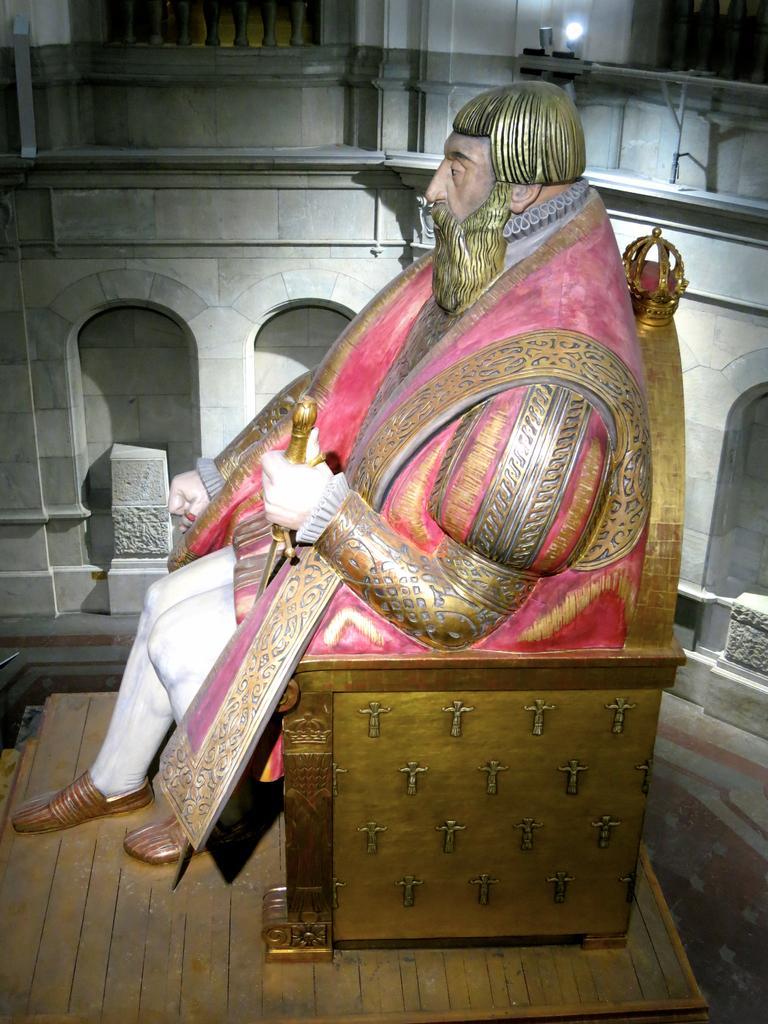How would you summarize this image in a sentence or two? In this picture we can see a statue on a platform and in the background we can see a wall, light and rods. 